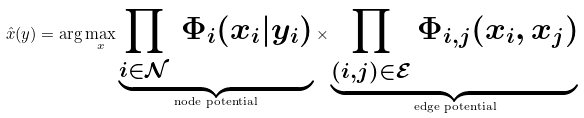Convert formula to latex. <formula><loc_0><loc_0><loc_500><loc_500>\hat { x } ( y ) = \arg \max _ { x } \underbrace { \prod _ { i \in \mathcal { N } } \, \Phi _ { i } ( x _ { i } | y _ { i } ) } _ { \text {node potential} } \times \underbrace { \prod _ { ( i , j ) \in \mathcal { E } } \Phi _ { i , j } ( x _ { i } , x _ { j } ) } _ { \text {edge potential} }</formula> 